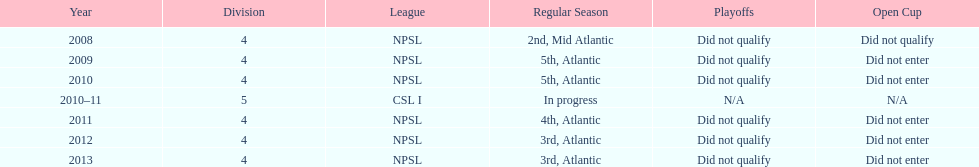Apart from npsl, which league has ny men's soccer team participated in? CSL I. Can you parse all the data within this table? {'header': ['Year', 'Division', 'League', 'Regular Season', 'Playoffs', 'Open Cup'], 'rows': [['2008', '4', 'NPSL', '2nd, Mid Atlantic', 'Did not qualify', 'Did not qualify'], ['2009', '4', 'NPSL', '5th, Atlantic', 'Did not qualify', 'Did not enter'], ['2010', '4', 'NPSL', '5th, Atlantic', 'Did not qualify', 'Did not enter'], ['2010–11', '5', 'CSL I', 'In progress', 'N/A', 'N/A'], ['2011', '4', 'NPSL', '4th, Atlantic', 'Did not qualify', 'Did not enter'], ['2012', '4', 'NPSL', '3rd, Atlantic', 'Did not qualify', 'Did not enter'], ['2013', '4', 'NPSL', '3rd, Atlantic', 'Did not qualify', 'Did not enter']]} 